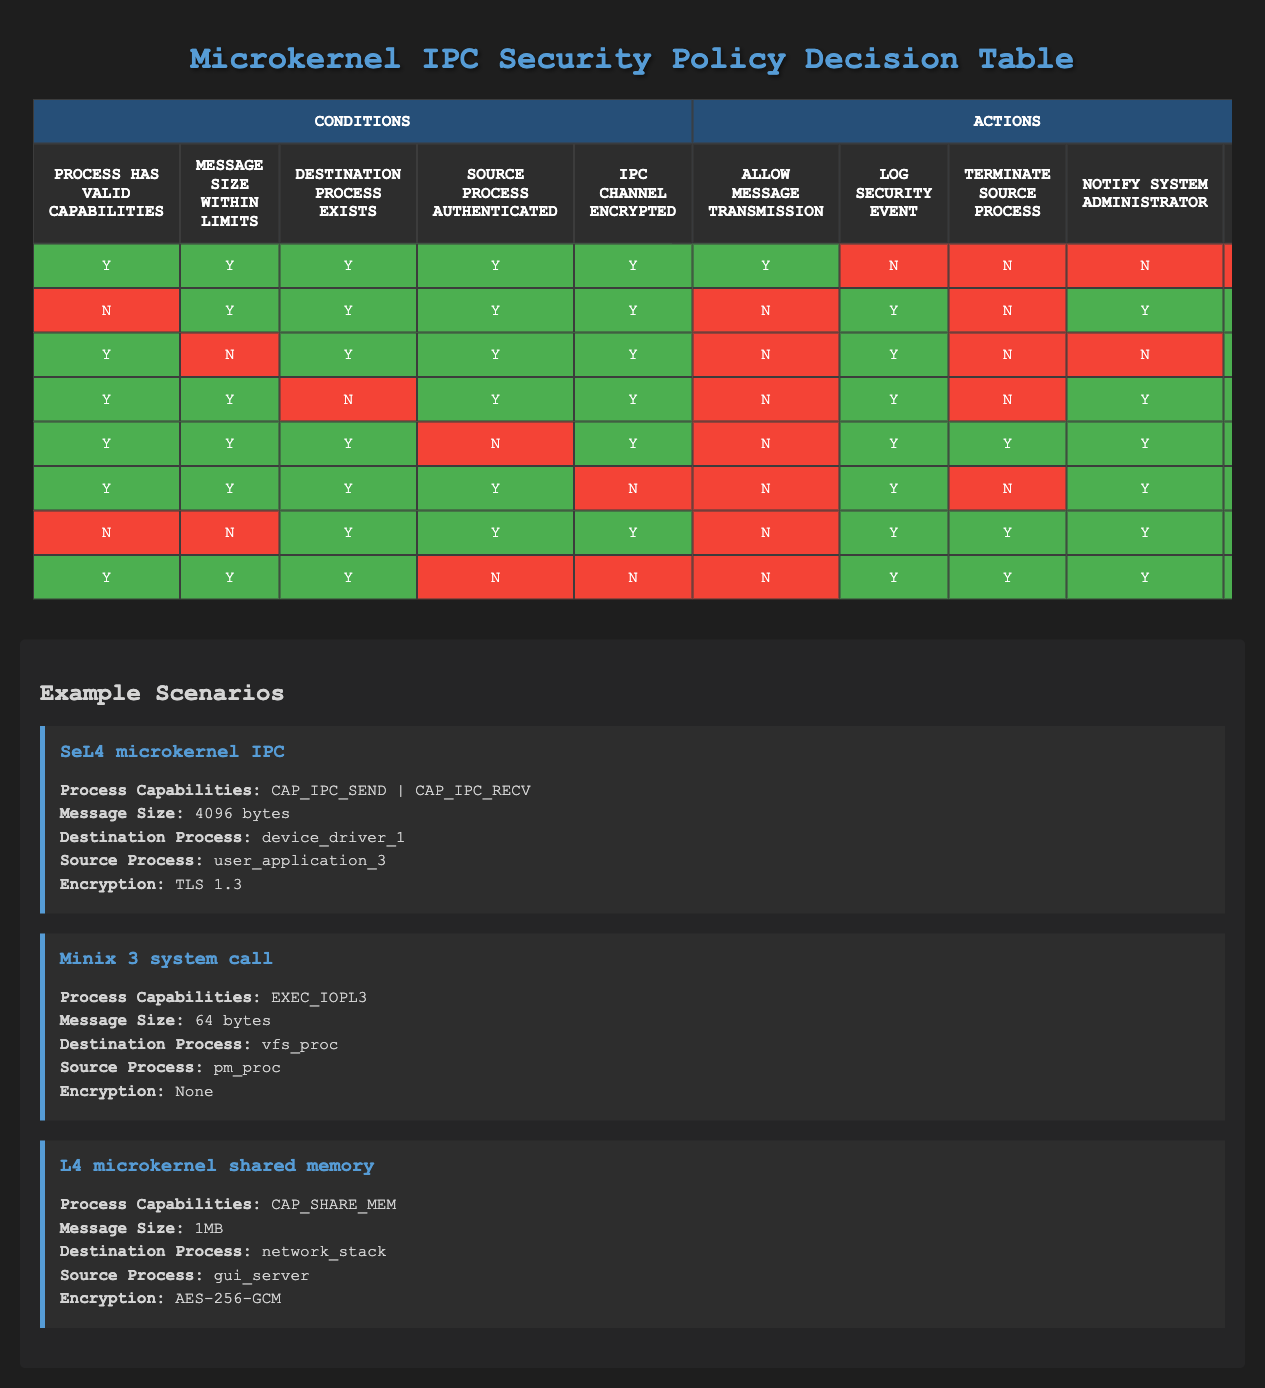What is the maximum number of actions that can occur when all conditions are met? Referring to the table, in the first rule where all conditions are true, the actions for "Allow message transmission" is true, while all other actions are false. Therefore, the maximum number of actions is one action when all conditions are met.
Answer: One In how many rules is the message rejected if the destination process exists? Looking at the rules, if the destination process exists (the third column), there are two instances where the "Reject message" action is true. These occur in rules 2, 3, 4, 5, 6, 7, and 8, but since we focus only on the rows where the third condition is true, we find that rules 2, 4, 5, and 6 apply, leading to a total of four occurrences where the message is rejected while the destination exists.
Answer: Four Is the source process authenticated a requirement for allowing message transmission in any rule? Checking the rules, there is only one instance where the source process is authenticated (fourth column) and the message is allowed to be transmitted, specifically in rule 1. In all other rules where message transmission is allowed, the source process must also be authenticated. Thus, the answer is yes.
Answer: Yes What action is taken if the IPC channel is not encrypted and the source process is authenticated? Reviewing the table under rule 6 where the IPC channel is not encrypted while the source process is authenticated, the message will be rejected, logged, and the system administrator will be notified. Thus, the specific action taken is to reject the message while logging the security event and notifying the administrator.
Answer: Reject message, log security event, notify administrator How many rules result in a security event being logged when the message size exceeds limits? In the table, none of the rules indicate that when the message size exceeds allowable limits, a security event is logged. By evaluating the rows, we find that the only action currently allowed when these conditions exist does not include logging, leading to the conclusion that it does not apply in these instances.
Answer: Zero Is there a scenario where the message transmission is allowed, but the IPC channel is not encrypted? Rule 6 indicates that when the conditions specify the IPC channel is not encrypted, there is no allowance for message transmission. Thus, there is no occurrence in which message transmission is allowed despite the IPC channel being unencrypted.
Answer: No What is the total number of actions when all conditions are false? Reviewing the rows where all conditions are false shows that for this scenario, the actions that take place include logging the security event, terminating the source process, and notifying the system administrator. Consequently, all three of these actions occur.
Answer: Three Under which circumstances are both the source process and the destination process validated but the message still rejected? Rule 5 illustrates that the rejection occurs even when both processes are validated under certain circumstances such as the source process being authenticated while the IPC channel remains unencrypted. Therefore, in this unique instance, the message is still rejected despite the validation of processes.
Answer: When the IPC channel is not encrypted How many total actions apply when the message size is within limits but the source process is not authenticated? Referring to the rules, in rule 2 where the message size is within limits but the source process is not authenticated leads to the actions of logging the security event and notifying the system administrator. Therefore, two actions apply under these conditions.
Answer: Two 